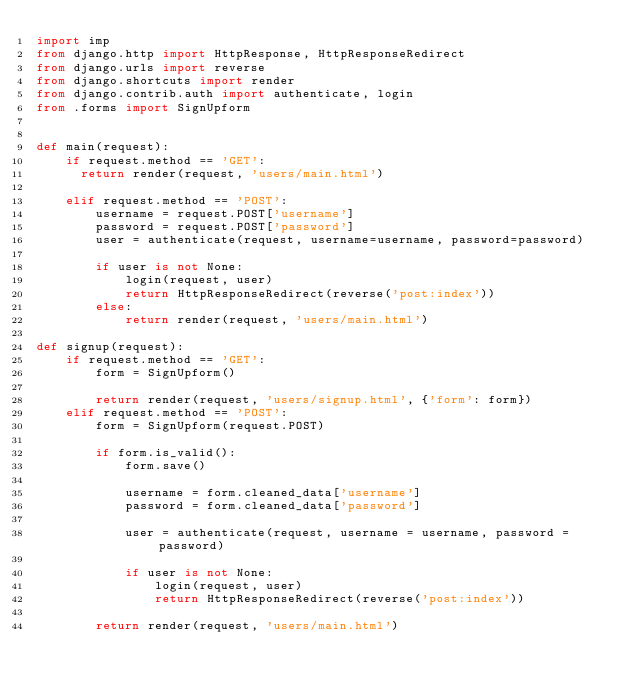<code> <loc_0><loc_0><loc_500><loc_500><_Python_>import imp
from django.http import HttpResponse, HttpResponseRedirect
from django.urls import reverse
from django.shortcuts import render
from django.contrib.auth import authenticate, login
from .forms import SignUpform


def main(request):
    if request.method == 'GET':
      return render(request, 'users/main.html')

    elif request.method == 'POST':
        username = request.POST['username']
        password = request.POST['password']
        user = authenticate(request, username=username, password=password)

        if user is not None:
            login(request, user)
            return HttpResponseRedirect(reverse('post:index'))
        else:
            return render(request, 'users/main.html')

def signup(request):
    if request.method == 'GET':
        form = SignUpform()
        
        return render(request, 'users/signup.html', {'form': form})
    elif request.method == 'POST':
        form = SignUpform(request.POST)
        
        if form.is_valid():
            form.save()
            
            username = form.cleaned_data['username']
            password = form.cleaned_data['password']
            
            user = authenticate(request, username = username, password = password)
            
            if user is not None:
                login(request, user)
                return HttpResponseRedirect(reverse('post:index'))
            
        return render(request, 'users/main.html')
        </code> 